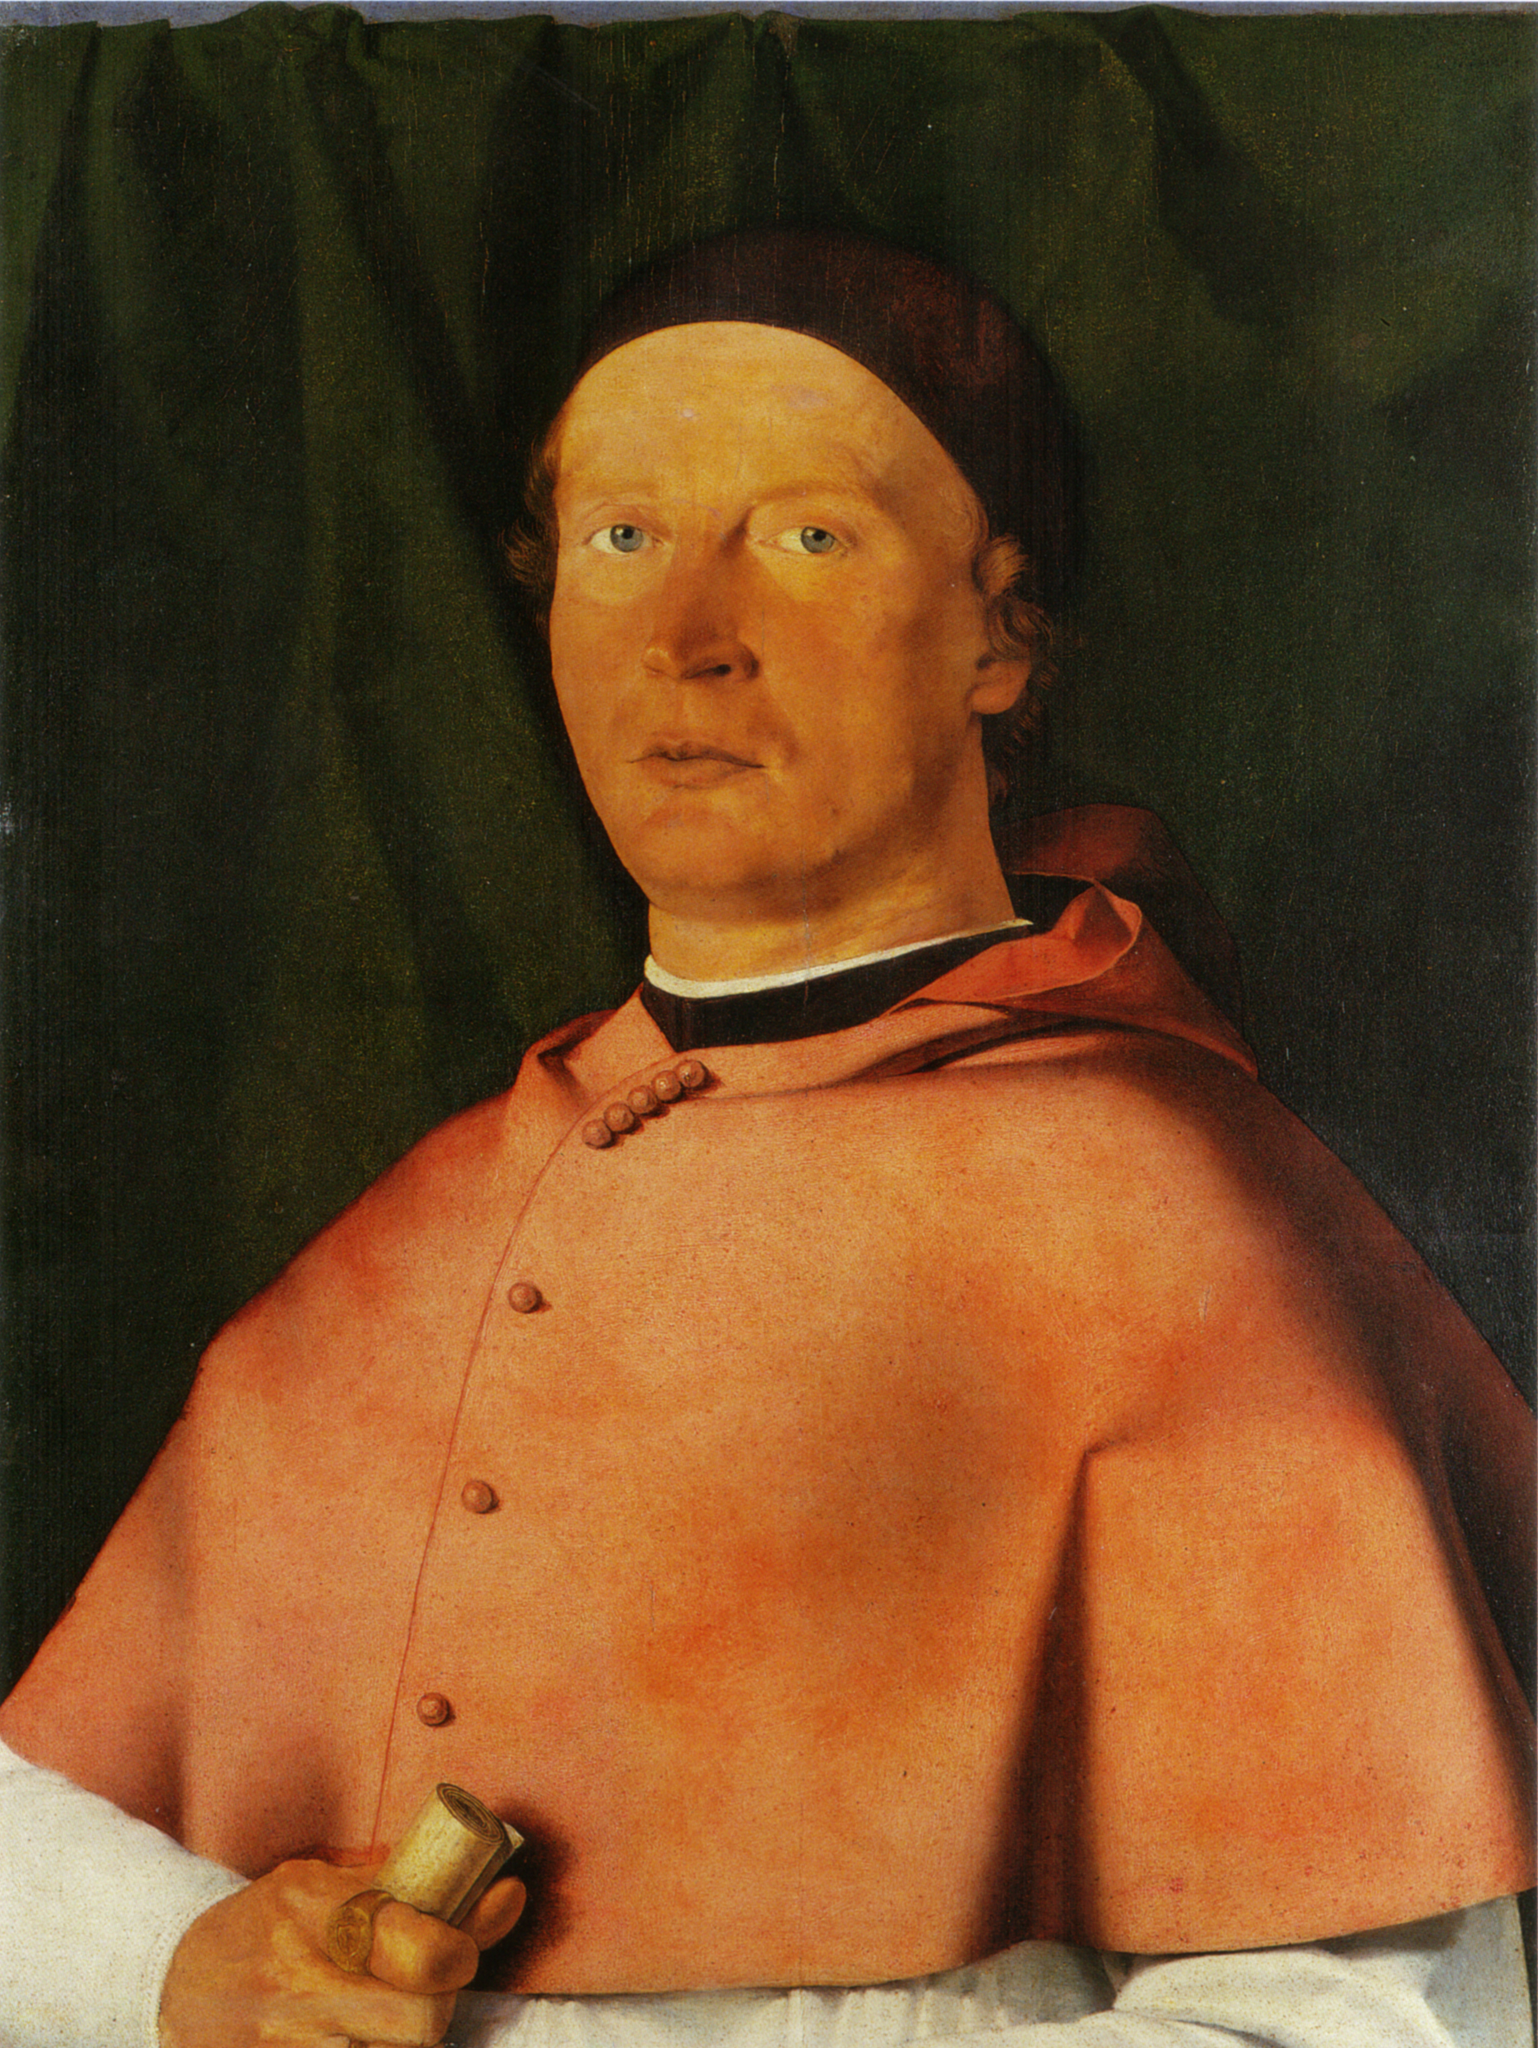What emotions do you perceive in this man's facial expression? The man’s facial expression conveys a mix of calm, contemplation, and perhaps a touch of solemnity. His slightly raised eyebrows and the gentle yet firm set of his mouth suggest someone deep in thought, possibly reflecting on matters of great importance. There is a sense of quiet confidence and inner assurance, indicating a man who is well aware of his responsibilities and position. The expression speaks to a life filled with duty, knowledge, and a certain level of gravitas, fitting for someone of apparent high rank and significance. 